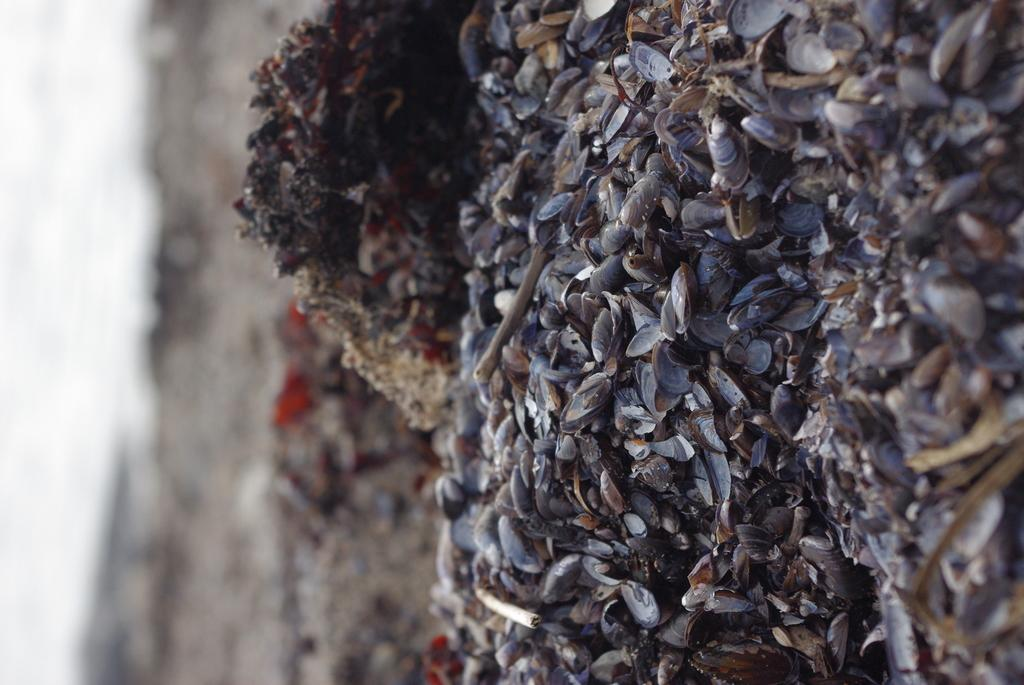What type of shells can be seen on the right side of the image? There are oyster shells on the right side of the image. How many rings can be seen on the kitty in the image? There is no kitty present in the image, and therefore no rings can be seen on it. 